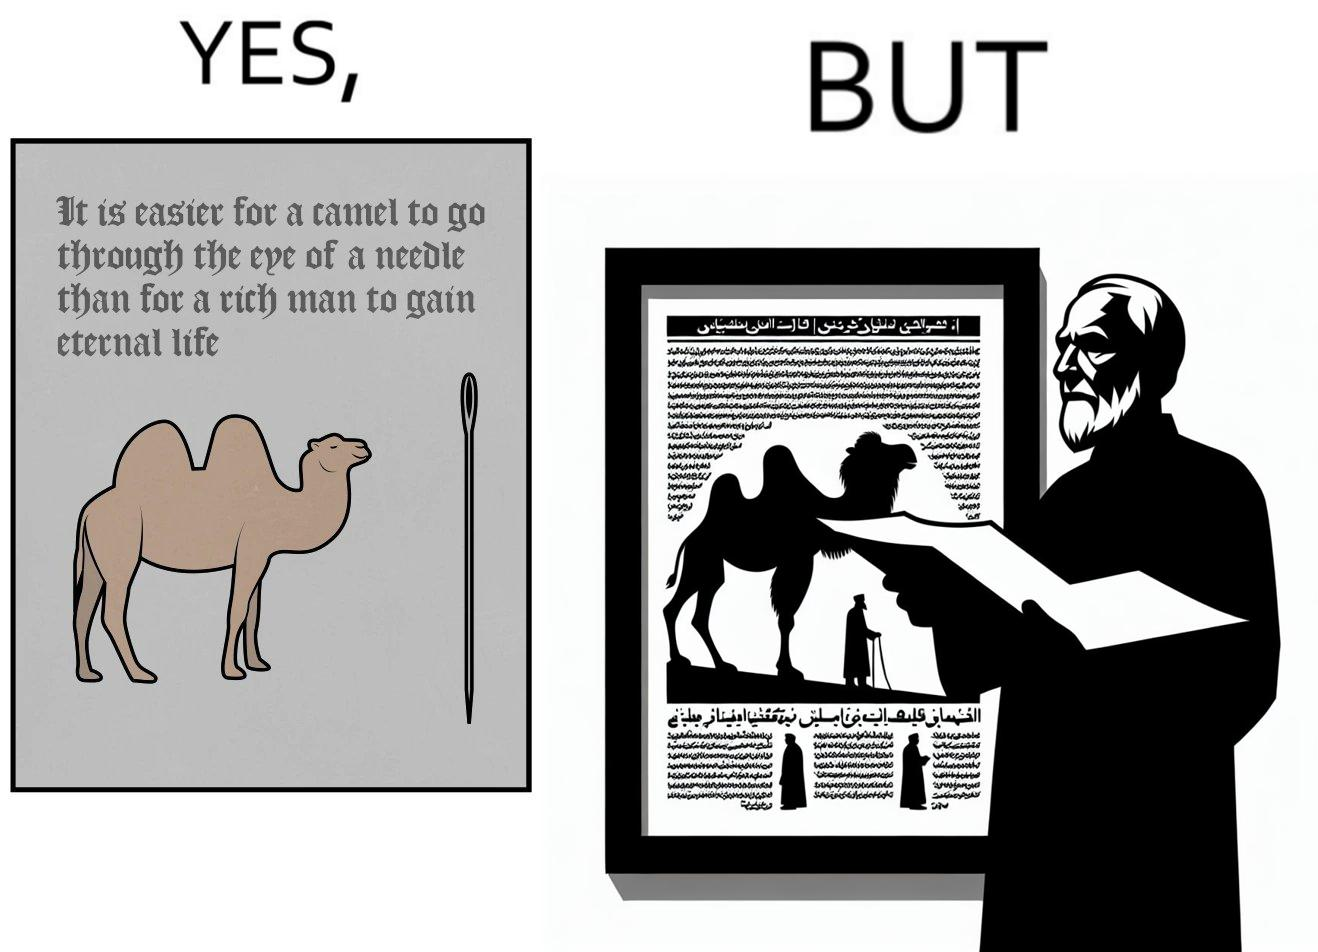Is this image satirical or non-satirical? Yes, this image is satirical. 